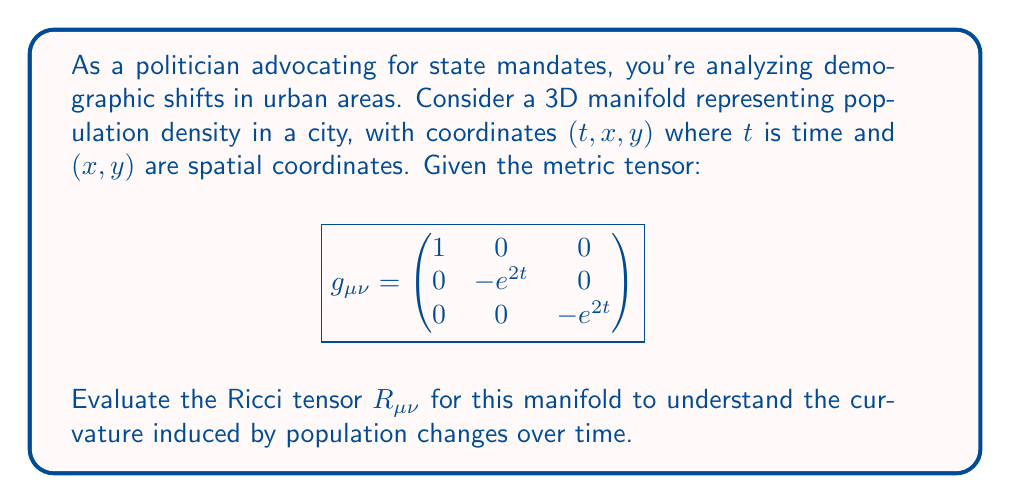Show me your answer to this math problem. To evaluate the Ricci tensor, we'll follow these steps:

1) First, calculate the Christoffel symbols $\Gamma^\alpha_{\mu\nu}$ using:

   $$\Gamma^\alpha_{\mu\nu} = \frac{1}{2}g^{\alpha\beta}(\partial_\mu g_{\nu\beta} + \partial_\nu g_{\mu\beta} - \partial_\beta g_{\mu\nu})$$

2) The non-zero Christoffel symbols are:
   $$\Gamma^1_{11} = \Gamma^2_{12} = \Gamma^2_{21} = \Gamma^3_{13} = \Gamma^3_{31} = 1$$

3) Next, calculate the Riemann tensor $R^\alpha_{\beta\mu\nu}$ using:

   $$R^\alpha_{\beta\mu\nu} = \partial_\mu \Gamma^\alpha_{\beta\nu} - \partial_\nu \Gamma^\alpha_{\beta\mu} + \Gamma^\alpha_{\sigma\mu}\Gamma^\sigma_{\beta\nu} - \Gamma^\alpha_{\sigma\nu}\Gamma^\sigma_{\beta\mu}$$

4) The non-zero components of the Riemann tensor are:
   $$R^1_{212} = R^1_{313} = e^{2t}$$

5) Finally, calculate the Ricci tensor $R_{\mu\nu}$ by contracting the Riemann tensor:

   $$R_{\mu\nu} = R^\alpha_{\mu\alpha\nu}$$

6) The non-zero components of the Ricci tensor are:
   $$R_{11} = -2$$
   $$R_{22} = R_{33} = -e^{2t}$$

Therefore, the Ricci tensor in matrix form is:

$$R_{\mu\nu} = \begin{pmatrix}
-2 & 0 & 0 \\
0 & -e^{2t} & 0 \\
0 & 0 & -e^{2t}
\end{pmatrix}$$
Answer: $$R_{\mu\nu} = \begin{pmatrix}
-2 & 0 & 0 \\
0 & -e^{2t} & 0 \\
0 & 0 & -e^{2t}
\end{pmatrix}$$ 